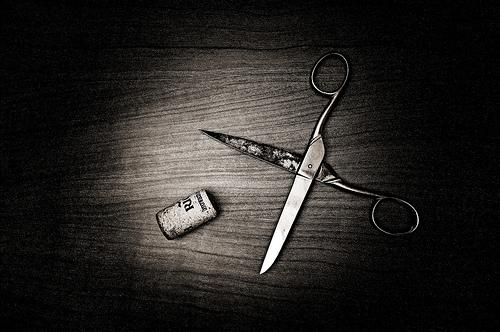Identify the sentiment evoked by the image. The image evokes a casual, everyday sentiment, depicting a common scene of household objects on a table. Explain the position and interaction of the scissors and the cork. The scissors are open with the wine cork placed between the blades, as if the scissors are attempting to cut or hold the cork. Can you tell me what object is placed near the primary object in the scene? A wine cork is situated next to the open scissors on the wooden surface. Enumerate the various parts and aspects of the scissors. The scissors have discolored, dirty blades, loop handles, a small connecting screw, and a top and bottom half. Provide a detailed description of the primary object in the image. An open pair of metal scissors rests on a wooden surface with a discolored blade and loop handles connected by a small screw. Evaluate the image quality based on the provided information. The image quality appears to be decent, with distinct objects and clear details such as the wooden surface grain and individual scissor parts. Determine the purpose or possible use of the scene shown in the image. The scene could depict a casual, everyday scenario of someone using scissors to remove a wine cork label or hold the cork for another purpose. How many handles do the scissors have and describe their location. The scissors have two loop handles – the right handle is on the top left and the left handle is on the bottom right. How many objects can be seen in this image and what are they? There are two objects visible in the image – a pair of open scissors and a wine cork. What kind of surface are the objects resting on? The objects, including the scissors and cork, rest upon a wooden surface with visible grain. Is the object next to the scissors a book? The image has a rectangular object next to the scissors, but there is no mention of it being a book. Where is the small screw connecting the scissors located? X:305 Y:162 Width:7 Height:7 Point out any unusual or unexpected aspects in the image. The scissors being open with a wine cork between the blades is somewhat unexpected. Which object is positioned between the scissor blades? wine cork X:155 Y:188 Width:64 Height:64 When asked about the object next to the scissors, which option will you choose? 1. A smartphone 2. A cork 3. A ruler 2. A cork Is there any interaction between the objects in the image? Yes, the wine cork is between the scissor blades. What is the shape of the object next to the scissors? rectangle X:130 Y:160 Width:103 Height:103 How would you describe the surface on which the scissors are placed? a wooden surface with visible wood grain What material are the scissors made of? metal Are the scissors made of plastic? The image has a pair of scissors, but they are described as metal, not plastic. Is the pair of scissors closed on the table? The image has a pair of scissors, but they are open, not closed. Is there any evidence of corrosion or dirt on the scissors? Yes, there is a dirty and discolored blade. Describe the main object in the image. A pair of open metal scissors on a wooden surface. Is the cork on the table or hanging from a string? The cork is on the table. Locate sections with distinct textures in the image. the grain of the wood X:48 Y:59 Width:284 Height:284 Can you find a wine bottle on the wooden surface? The image has a wine cork, but there is no mention of a wine bottle. Is the wooden surface perfectly smooth? The image has a wooden surface, but it is described as having a visible grain, which suggests it's not perfectly smooth. How is the overall quality of the image? The image is clear with a good representation of the objects present. Can you detect any potential emotion or sentiment in this image? Neutral, as it is just an image of scissors and a cork. Which caption refers to the top part of the scissors? top half of scissors X:260 Y:51 Width:90 Height:90 Identify the positions and dimensions of the scissors in the image. X:165 Y:39 Width:290 Height:290 Can you see a clean blade on the scissors? The image has a blade on the scissors, but it is described as dirty, not clean. Describe the attributes of the blade on one side of the scissors. dirty and discolored X:197 Y:126 Width:100 Height:100 State the position and size of the left handle of the scissors. X:350 Y:168 Width:72 Height:72 Is there any text present within the image? No, there is no text in the image. 